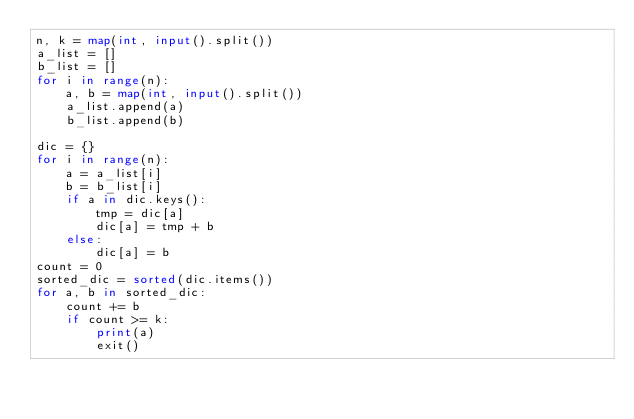Convert code to text. <code><loc_0><loc_0><loc_500><loc_500><_Python_>n, k = map(int, input().split())
a_list = []
b_list = []
for i in range(n):
    a, b = map(int, input().split())
    a_list.append(a)
    b_list.append(b)

dic = {}
for i in range(n):
    a = a_list[i]
    b = b_list[i]
    if a in dic.keys():
        tmp = dic[a]
        dic[a] = tmp + b
    else:
        dic[a] = b
count = 0
sorted_dic = sorted(dic.items())
for a, b in sorted_dic:
    count += b
    if count >= k:
        print(a)
        exit()</code> 